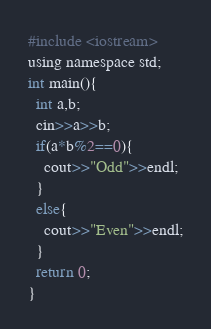Convert code to text. <code><loc_0><loc_0><loc_500><loc_500><_Python_>#include <iostream>
using namespace std;
int main(){
  int a,b;
  cin>>a>>b;
  if(a*b%2==0){
    cout>>"Odd">>endl;
  }
  else{
    cout>>"Even">>endl;
  }
  return 0;
}</code> 